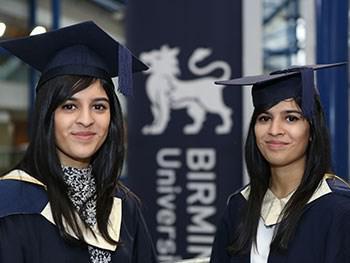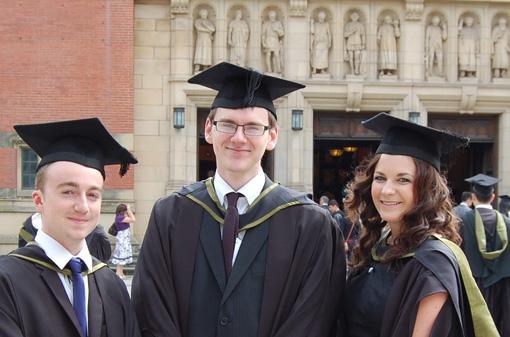The first image is the image on the left, the second image is the image on the right. Considering the images on both sides, is "The graduates in the right image are wearing blue gowns." valid? Answer yes or no. No. The first image is the image on the left, the second image is the image on the right. Assess this claim about the two images: "One image shows two forward-facing dark-haired female graduates in the foreground, wearing matching hats and robes with a white V at the collar.". Correct or not? Answer yes or no. Yes. 